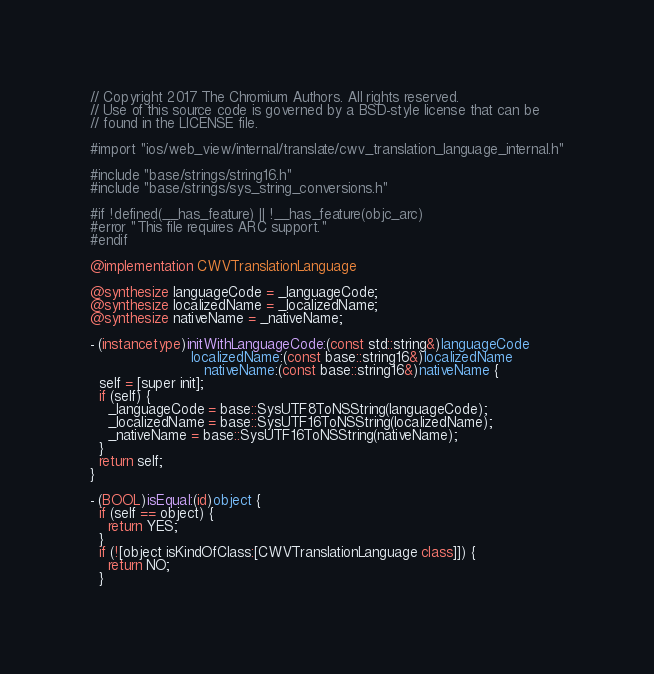<code> <loc_0><loc_0><loc_500><loc_500><_ObjectiveC_>// Copyright 2017 The Chromium Authors. All rights reserved.
// Use of this source code is governed by a BSD-style license that can be
// found in the LICENSE file.

#import "ios/web_view/internal/translate/cwv_translation_language_internal.h"

#include "base/strings/string16.h"
#include "base/strings/sys_string_conversions.h"

#if !defined(__has_feature) || !__has_feature(objc_arc)
#error "This file requires ARC support."
#endif

@implementation CWVTranslationLanguage

@synthesize languageCode = _languageCode;
@synthesize localizedName = _localizedName;
@synthesize nativeName = _nativeName;

- (instancetype)initWithLanguageCode:(const std::string&)languageCode
                       localizedName:(const base::string16&)localizedName
                          nativeName:(const base::string16&)nativeName {
  self = [super init];
  if (self) {
    _languageCode = base::SysUTF8ToNSString(languageCode);
    _localizedName = base::SysUTF16ToNSString(localizedName);
    _nativeName = base::SysUTF16ToNSString(nativeName);
  }
  return self;
}

- (BOOL)isEqual:(id)object {
  if (self == object) {
    return YES;
  }
  if (![object isKindOfClass:[CWVTranslationLanguage class]]) {
    return NO;
  }
</code> 